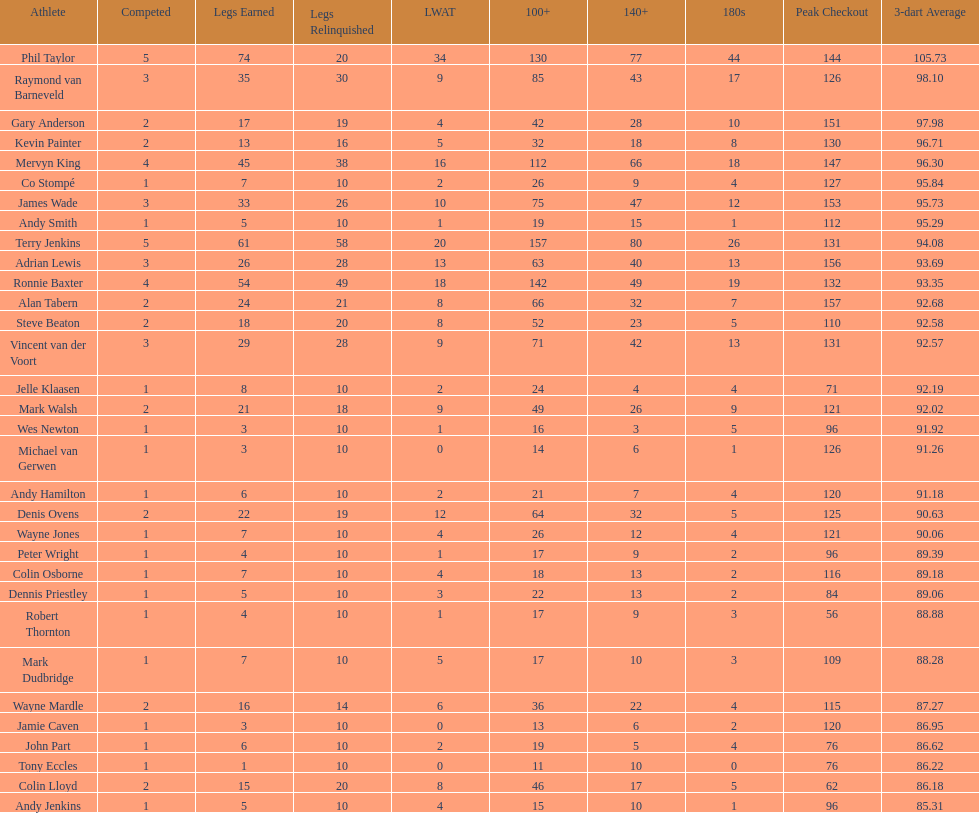Which player lost the least? Co Stompé, Andy Smith, Jelle Klaasen, Wes Newton, Michael van Gerwen, Andy Hamilton, Wayne Jones, Peter Wright, Colin Osborne, Dennis Priestley, Robert Thornton, Mark Dudbridge, Jamie Caven, John Part, Tony Eccles, Andy Jenkins. 